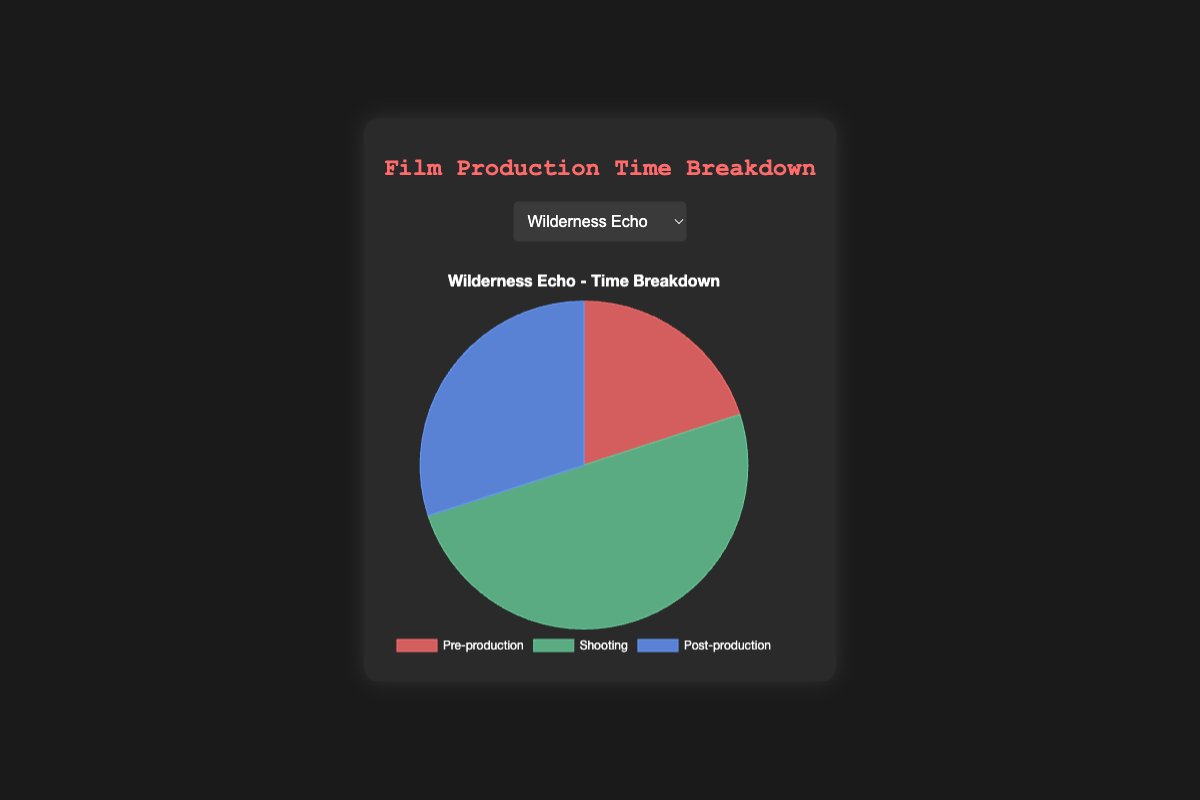Which phase takes the largest portion of time for "Wilderness Echo"? The "Wilderness Echo" pie chart shows three phases with different sizes. The largest portion of the pie chart is for the Shooting phase.
Answer: Shooting What is the difference in time allocation between Pre-production and Post-production for "Northern Shadows"? The "Northern Shadows" pie chart shows 25% in Pre-production and 30% in Post-production. The difference is 30% - 25%.
Answer: 5% Which film has the highest percentage of time spent on Shooting? By comparing the Shooting percentages of all the films, "Frozen Path" has the highest percentage with 60%.
Answer: Frozen Path How much total time is spent on Pre-production and Post-production for "Aurora Borealis"? The "Aurora Borealis" pie chart shows Pre-production at 15% and Post-production at 30%. Their sum is 15% + 30%.
Answer: 45% Which film spends an equal amount of time on Pre-production and Post-production? By examining each film's pre-production and post-production times, "Timberland Tales" is the one that spends 30% on both.
Answer: Timberland Tales For "Lake of Secrets", is the time spent on Shooting greater than the combined time of Pre-production and Post-production? The "Lake of Secrets" pie chart shows Shooting at 50%, Pre-production at 25%, and Post-production at 25%. The combined time of Pre and Post-production is 25% + 25% = 50%, which equals the Shooting time.
Answer: No Among all films, which phase has the least variation in time allocation? Comparing the time spent in each phase, Post-production time remains constant at 30% for five films and only varies to 20% in "Frozen Path". Shooting and Pre-production have larger variances.
Answer: Post-production What is the average time spent in Pre-production across all six films? The Pre-production times are: 20, 25, 15, 30, 20, and 25. Their sum is 135. The average is 135/6.
Answer: 22.5 